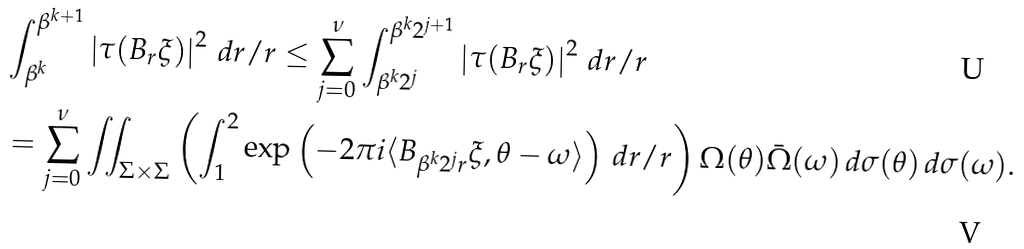Convert formula to latex. <formula><loc_0><loc_0><loc_500><loc_500>& \int _ { \beta ^ { k } } ^ { \beta ^ { k + 1 } } \left | \tau ( B _ { r } \xi ) \right | ^ { 2 } \, d r / r \leq \sum _ { j = 0 } ^ { \nu } \int _ { \beta ^ { k } 2 ^ { j } } ^ { \beta ^ { k } 2 ^ { j + 1 } } \left | \tau ( B _ { r } \xi ) \right | ^ { 2 } \, d r / r \\ & = \sum _ { j = 0 } ^ { \nu } \iint _ { \Sigma \times \Sigma } \left ( \int _ { 1 } ^ { 2 } \exp \left ( - 2 \pi i \langle B _ { \beta ^ { k } 2 ^ { j } r } \xi , \theta - \omega \rangle \right ) \, d r / r \right ) \Omega ( \theta ) \bar { \Omega } ( \omega ) \, d \sigma ( \theta ) \, d \sigma ( \omega ) .</formula> 